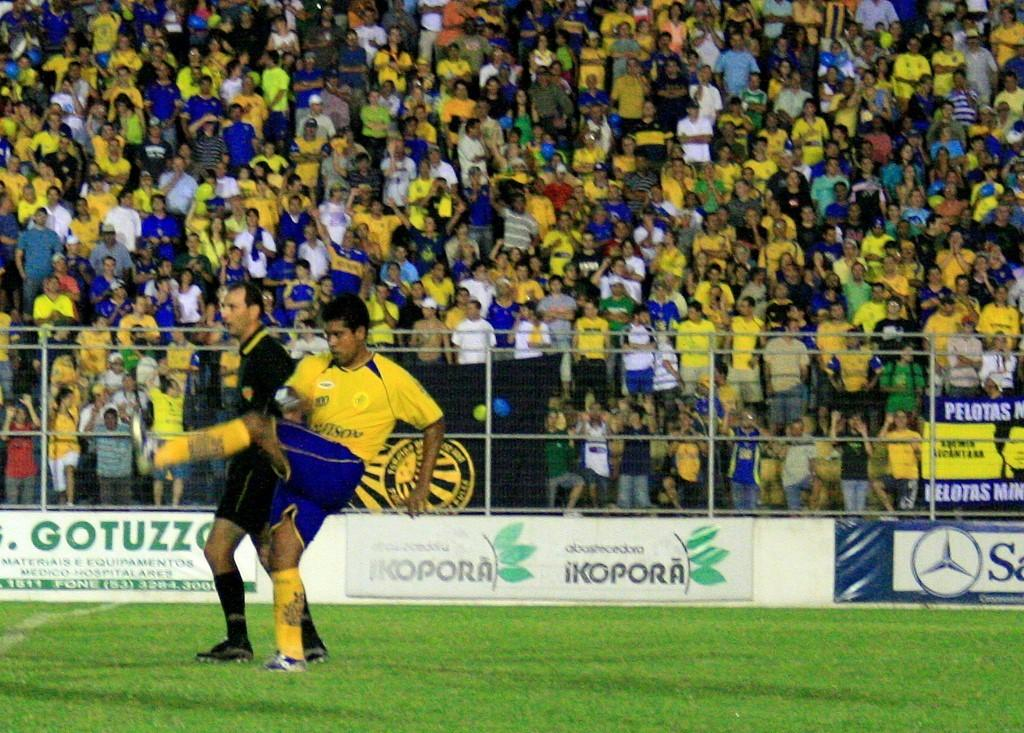<image>
Give a short and clear explanation of the subsequent image. The sign in the background of this football pitch says Gotuzzo. 